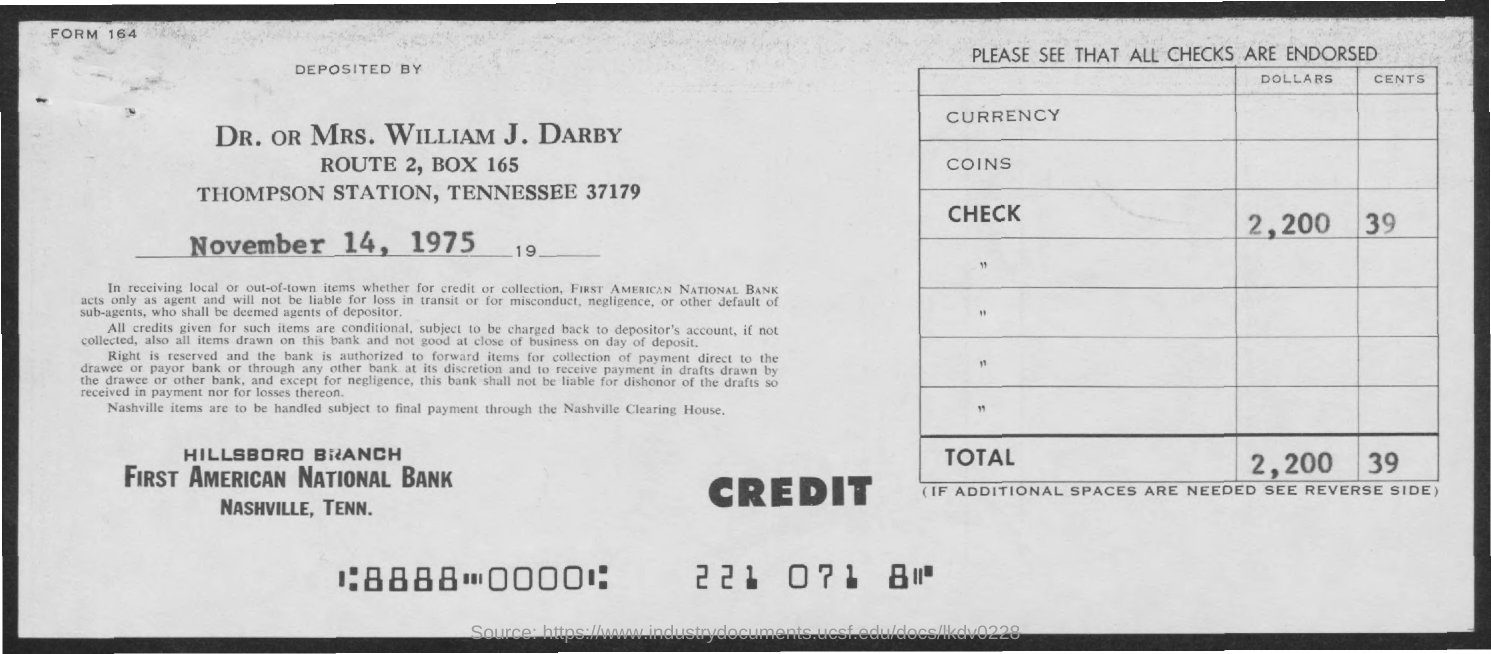Highlight a few significant elements in this photo. The date is November 14, 1975. 